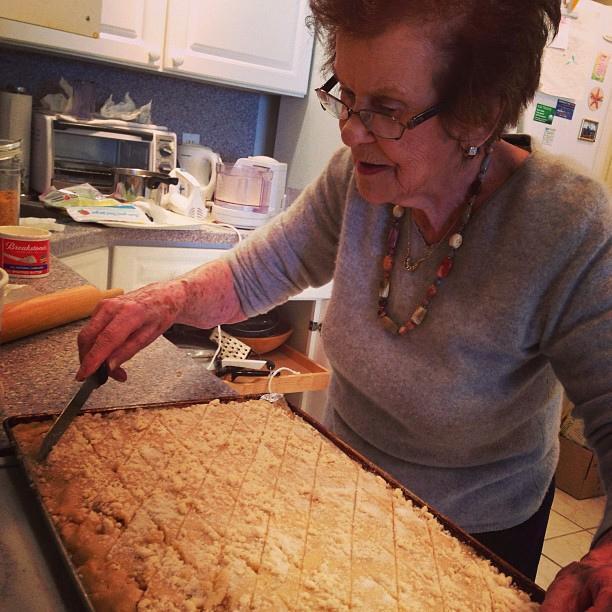Evaluate: Does the caption "The cake is across from the oven." match the image?
Answer yes or no. Yes. Evaluate: Does the caption "The oven is left of the cake." match the image?
Answer yes or no. No. Does the caption "The cake is in the oven." correctly depict the image?
Answer yes or no. No. Is the caption "The cake is inside the oven." a true representation of the image?
Answer yes or no. No. Does the caption "The person is at the right side of the cake." correctly depict the image?
Answer yes or no. Yes. 